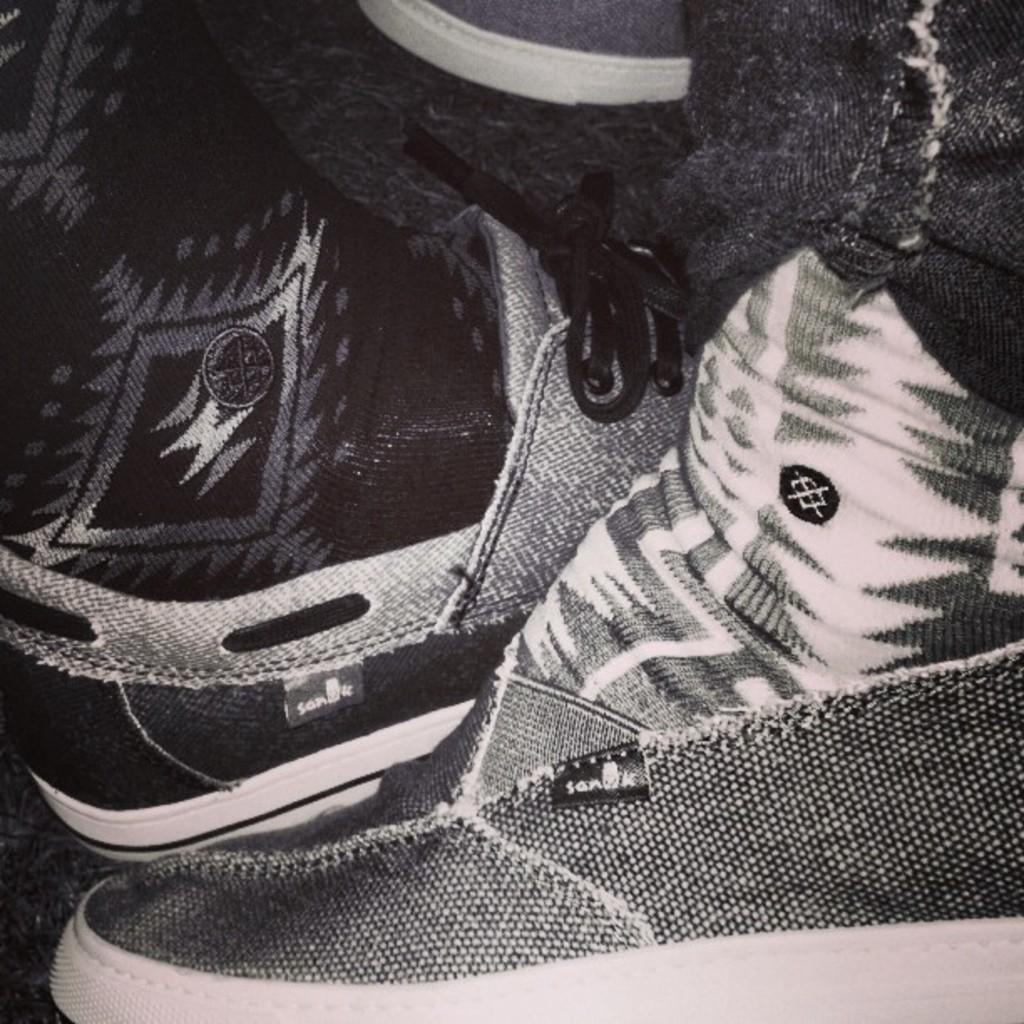What can be seen in the foreground of the image? Two persons' legs are visible in the foreground of the image. What are the persons wearing on their feet? The persons are wearing shoes. Can you describe anything else related to footwear in the image? There is another shoe visible in the background of the image. What is visible at the bottom of the image? The floor is visible at the bottom of the image. What type of island can be seen in the background of the image? There is no island present in the image; it only features legs, shoes, and a floor. How many potatoes are visible in the image? There are no potatoes visible in the image. 